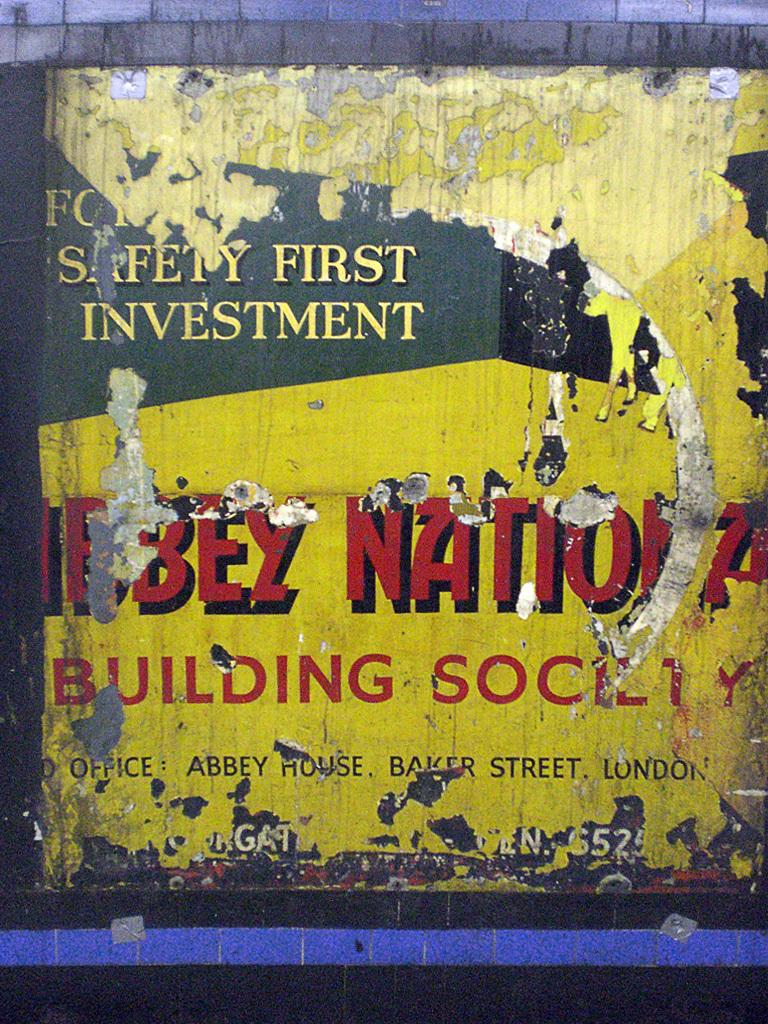<image>
Write a terse but informative summary of the picture. A worn out sign is for Safety First Investment. 